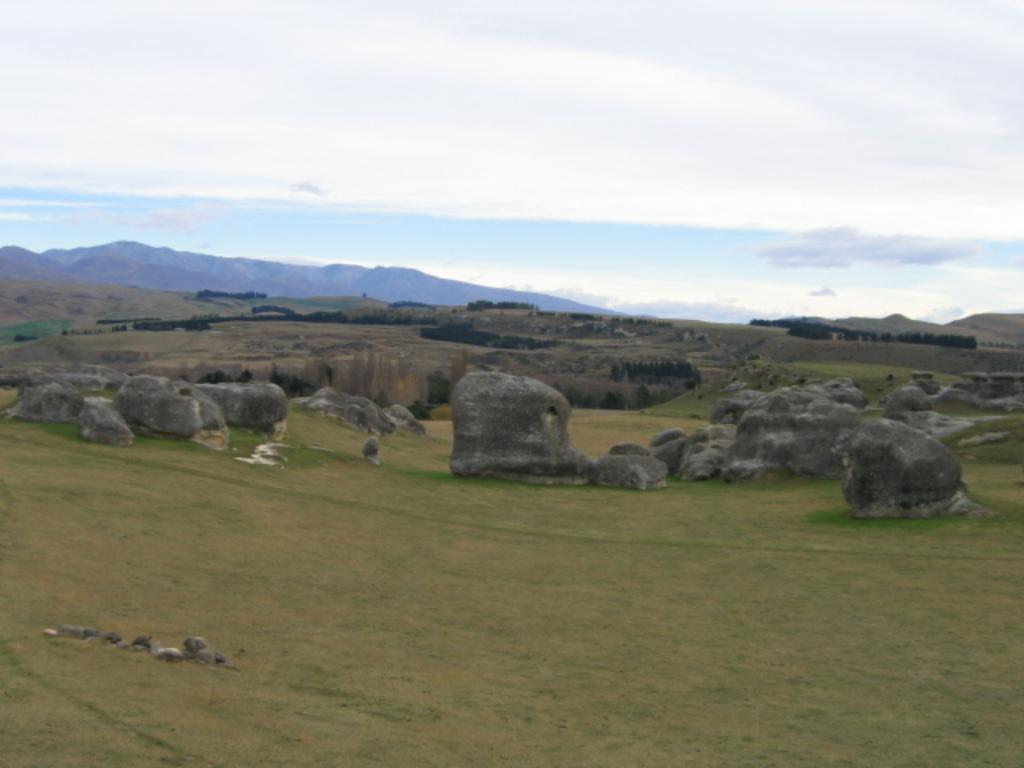Where was the image taken? The image was clicked outside. What can be seen in the middle of the image? There are rocks and trees in the middle of the image. What is visible at the top of the image? The sky is visible at the top of the image. How many basketballs can be seen in the image? There are no basketballs present in the image. What type of arm is visible in the image? There is no arm visible in the image. 